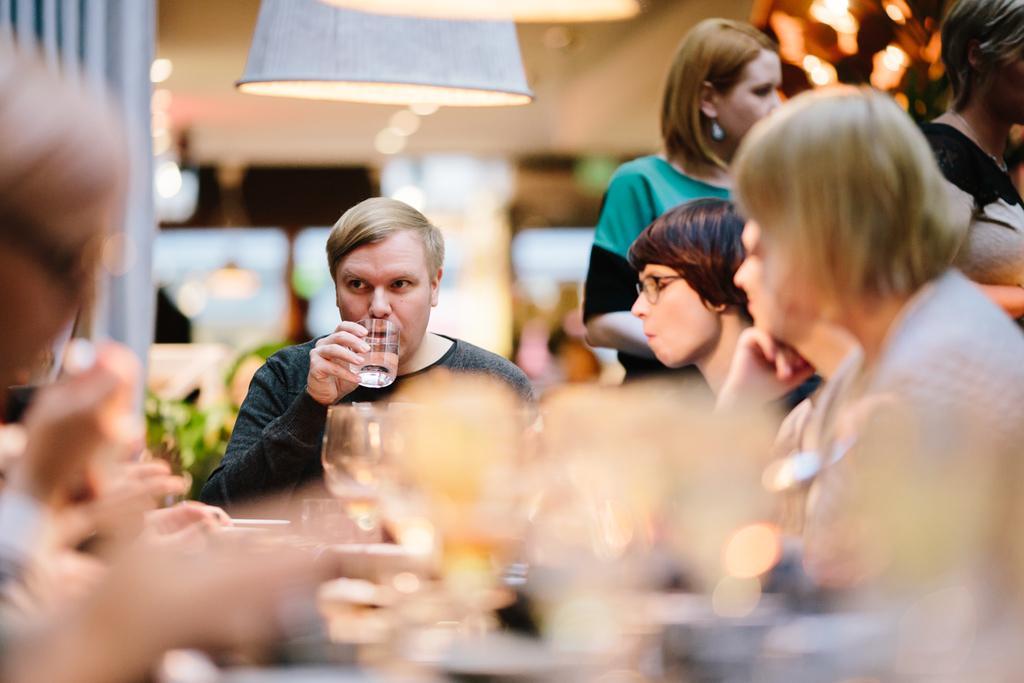Describe this image in one or two sentences. In the foreground of this image, there are persons sitting around the table, where we can see blurred glasses and few objects on it. In the background, there are two women standing, blurred objects in the background and lamps on the top. 